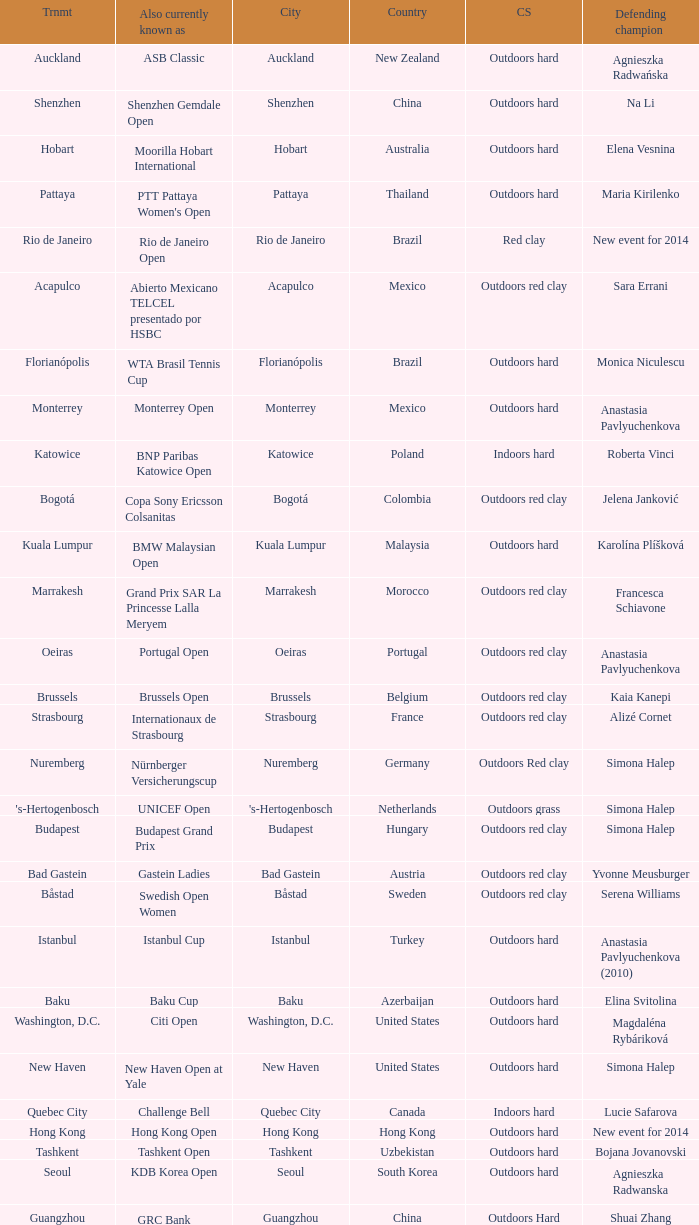How many defending champs from thailand? 1.0. 